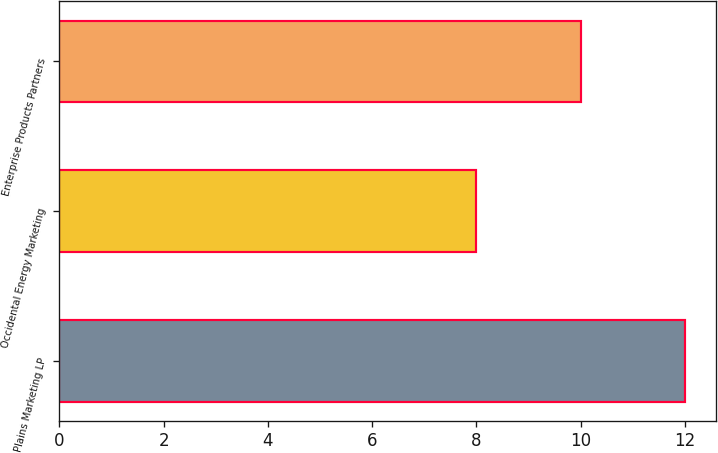Convert chart. <chart><loc_0><loc_0><loc_500><loc_500><bar_chart><fcel>Plains Marketing LP<fcel>Occidental Energy Marketing<fcel>Enterprise Products Partners<nl><fcel>12<fcel>8<fcel>10<nl></chart> 